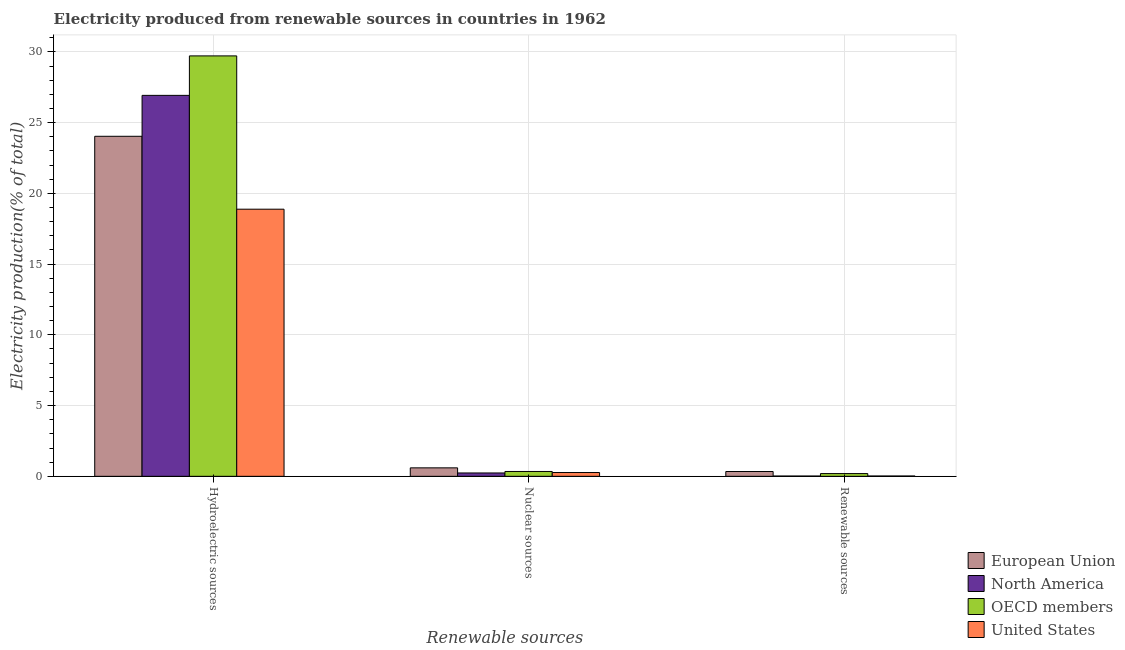How many different coloured bars are there?
Provide a succinct answer. 4. Are the number of bars per tick equal to the number of legend labels?
Ensure brevity in your answer.  Yes. Are the number of bars on each tick of the X-axis equal?
Your response must be concise. Yes. How many bars are there on the 3rd tick from the left?
Make the answer very short. 4. How many bars are there on the 3rd tick from the right?
Ensure brevity in your answer.  4. What is the label of the 2nd group of bars from the left?
Provide a succinct answer. Nuclear sources. What is the percentage of electricity produced by nuclear sources in OECD members?
Ensure brevity in your answer.  0.34. Across all countries, what is the maximum percentage of electricity produced by renewable sources?
Provide a short and direct response. 0.34. Across all countries, what is the minimum percentage of electricity produced by hydroelectric sources?
Make the answer very short. 18.88. What is the total percentage of electricity produced by hydroelectric sources in the graph?
Offer a terse response. 99.56. What is the difference between the percentage of electricity produced by hydroelectric sources in European Union and that in OECD members?
Your answer should be very brief. -5.68. What is the difference between the percentage of electricity produced by renewable sources in European Union and the percentage of electricity produced by hydroelectric sources in North America?
Offer a terse response. -26.59. What is the average percentage of electricity produced by nuclear sources per country?
Your answer should be very brief. 0.36. What is the difference between the percentage of electricity produced by renewable sources and percentage of electricity produced by hydroelectric sources in United States?
Provide a succinct answer. -18.86. In how many countries, is the percentage of electricity produced by hydroelectric sources greater than 10 %?
Give a very brief answer. 4. What is the ratio of the percentage of electricity produced by nuclear sources in North America to that in OECD members?
Your response must be concise. 0.69. Is the percentage of electricity produced by hydroelectric sources in North America less than that in United States?
Keep it short and to the point. No. What is the difference between the highest and the second highest percentage of electricity produced by hydroelectric sources?
Make the answer very short. 2.79. What is the difference between the highest and the lowest percentage of electricity produced by renewable sources?
Offer a very short reply. 0.32. In how many countries, is the percentage of electricity produced by renewable sources greater than the average percentage of electricity produced by renewable sources taken over all countries?
Keep it short and to the point. 2. What does the 3rd bar from the left in Renewable sources represents?
Offer a very short reply. OECD members. How many bars are there?
Provide a succinct answer. 12. Are all the bars in the graph horizontal?
Provide a succinct answer. No. What is the difference between two consecutive major ticks on the Y-axis?
Your answer should be compact. 5. Does the graph contain grids?
Ensure brevity in your answer.  Yes. How many legend labels are there?
Keep it short and to the point. 4. How are the legend labels stacked?
Provide a short and direct response. Vertical. What is the title of the graph?
Keep it short and to the point. Electricity produced from renewable sources in countries in 1962. What is the label or title of the X-axis?
Give a very brief answer. Renewable sources. What is the label or title of the Y-axis?
Your response must be concise. Electricity production(% of total). What is the Electricity production(% of total) of European Union in Hydroelectric sources?
Keep it short and to the point. 24.03. What is the Electricity production(% of total) of North America in Hydroelectric sources?
Your answer should be very brief. 26.93. What is the Electricity production(% of total) of OECD members in Hydroelectric sources?
Provide a succinct answer. 29.72. What is the Electricity production(% of total) in United States in Hydroelectric sources?
Keep it short and to the point. 18.88. What is the Electricity production(% of total) of European Union in Nuclear sources?
Your answer should be compact. 0.6. What is the Electricity production(% of total) of North America in Nuclear sources?
Offer a very short reply. 0.24. What is the Electricity production(% of total) in OECD members in Nuclear sources?
Offer a terse response. 0.34. What is the Electricity production(% of total) in United States in Nuclear sources?
Provide a succinct answer. 0.27. What is the Electricity production(% of total) of European Union in Renewable sources?
Make the answer very short. 0.34. What is the Electricity production(% of total) in North America in Renewable sources?
Offer a very short reply. 0.02. What is the Electricity production(% of total) of OECD members in Renewable sources?
Ensure brevity in your answer.  0.19. What is the Electricity production(% of total) in United States in Renewable sources?
Offer a very short reply. 0.02. Across all Renewable sources, what is the maximum Electricity production(% of total) in European Union?
Offer a terse response. 24.03. Across all Renewable sources, what is the maximum Electricity production(% of total) in North America?
Provide a succinct answer. 26.93. Across all Renewable sources, what is the maximum Electricity production(% of total) of OECD members?
Ensure brevity in your answer.  29.72. Across all Renewable sources, what is the maximum Electricity production(% of total) in United States?
Provide a short and direct response. 18.88. Across all Renewable sources, what is the minimum Electricity production(% of total) in European Union?
Give a very brief answer. 0.34. Across all Renewable sources, what is the minimum Electricity production(% of total) of North America?
Give a very brief answer. 0.02. Across all Renewable sources, what is the minimum Electricity production(% of total) of OECD members?
Keep it short and to the point. 0.19. Across all Renewable sources, what is the minimum Electricity production(% of total) in United States?
Your response must be concise. 0.02. What is the total Electricity production(% of total) of European Union in the graph?
Offer a very short reply. 24.97. What is the total Electricity production(% of total) in North America in the graph?
Your response must be concise. 27.18. What is the total Electricity production(% of total) of OECD members in the graph?
Your response must be concise. 30.25. What is the total Electricity production(% of total) of United States in the graph?
Make the answer very short. 19.17. What is the difference between the Electricity production(% of total) in European Union in Hydroelectric sources and that in Nuclear sources?
Give a very brief answer. 23.43. What is the difference between the Electricity production(% of total) of North America in Hydroelectric sources and that in Nuclear sources?
Ensure brevity in your answer.  26.69. What is the difference between the Electricity production(% of total) of OECD members in Hydroelectric sources and that in Nuclear sources?
Offer a terse response. 29.37. What is the difference between the Electricity production(% of total) in United States in Hydroelectric sources and that in Nuclear sources?
Your response must be concise. 18.61. What is the difference between the Electricity production(% of total) in European Union in Hydroelectric sources and that in Renewable sources?
Your response must be concise. 23.69. What is the difference between the Electricity production(% of total) in North America in Hydroelectric sources and that in Renewable sources?
Make the answer very short. 26.91. What is the difference between the Electricity production(% of total) of OECD members in Hydroelectric sources and that in Renewable sources?
Provide a succinct answer. 29.52. What is the difference between the Electricity production(% of total) of United States in Hydroelectric sources and that in Renewable sources?
Make the answer very short. 18.86. What is the difference between the Electricity production(% of total) in European Union in Nuclear sources and that in Renewable sources?
Your answer should be compact. 0.26. What is the difference between the Electricity production(% of total) in North America in Nuclear sources and that in Renewable sources?
Keep it short and to the point. 0.22. What is the difference between the Electricity production(% of total) of OECD members in Nuclear sources and that in Renewable sources?
Offer a very short reply. 0.15. What is the difference between the Electricity production(% of total) in United States in Nuclear sources and that in Renewable sources?
Your answer should be very brief. 0.25. What is the difference between the Electricity production(% of total) of European Union in Hydroelectric sources and the Electricity production(% of total) of North America in Nuclear sources?
Ensure brevity in your answer.  23.8. What is the difference between the Electricity production(% of total) in European Union in Hydroelectric sources and the Electricity production(% of total) in OECD members in Nuclear sources?
Keep it short and to the point. 23.69. What is the difference between the Electricity production(% of total) of European Union in Hydroelectric sources and the Electricity production(% of total) of United States in Nuclear sources?
Offer a terse response. 23.77. What is the difference between the Electricity production(% of total) in North America in Hydroelectric sources and the Electricity production(% of total) in OECD members in Nuclear sources?
Provide a short and direct response. 26.58. What is the difference between the Electricity production(% of total) of North America in Hydroelectric sources and the Electricity production(% of total) of United States in Nuclear sources?
Keep it short and to the point. 26.66. What is the difference between the Electricity production(% of total) of OECD members in Hydroelectric sources and the Electricity production(% of total) of United States in Nuclear sources?
Offer a very short reply. 29.45. What is the difference between the Electricity production(% of total) in European Union in Hydroelectric sources and the Electricity production(% of total) in North America in Renewable sources?
Your answer should be very brief. 24.01. What is the difference between the Electricity production(% of total) in European Union in Hydroelectric sources and the Electricity production(% of total) in OECD members in Renewable sources?
Offer a terse response. 23.84. What is the difference between the Electricity production(% of total) of European Union in Hydroelectric sources and the Electricity production(% of total) of United States in Renewable sources?
Provide a succinct answer. 24.01. What is the difference between the Electricity production(% of total) of North America in Hydroelectric sources and the Electricity production(% of total) of OECD members in Renewable sources?
Give a very brief answer. 26.73. What is the difference between the Electricity production(% of total) of North America in Hydroelectric sources and the Electricity production(% of total) of United States in Renewable sources?
Keep it short and to the point. 26.9. What is the difference between the Electricity production(% of total) in OECD members in Hydroelectric sources and the Electricity production(% of total) in United States in Renewable sources?
Offer a terse response. 29.69. What is the difference between the Electricity production(% of total) of European Union in Nuclear sources and the Electricity production(% of total) of North America in Renewable sources?
Your answer should be compact. 0.58. What is the difference between the Electricity production(% of total) in European Union in Nuclear sources and the Electricity production(% of total) in OECD members in Renewable sources?
Your answer should be very brief. 0.41. What is the difference between the Electricity production(% of total) of European Union in Nuclear sources and the Electricity production(% of total) of United States in Renewable sources?
Keep it short and to the point. 0.58. What is the difference between the Electricity production(% of total) of North America in Nuclear sources and the Electricity production(% of total) of OECD members in Renewable sources?
Your answer should be very brief. 0.04. What is the difference between the Electricity production(% of total) of North America in Nuclear sources and the Electricity production(% of total) of United States in Renewable sources?
Give a very brief answer. 0.21. What is the difference between the Electricity production(% of total) in OECD members in Nuclear sources and the Electricity production(% of total) in United States in Renewable sources?
Offer a terse response. 0.32. What is the average Electricity production(% of total) in European Union per Renewable sources?
Make the answer very short. 8.32. What is the average Electricity production(% of total) in North America per Renewable sources?
Offer a very short reply. 9.06. What is the average Electricity production(% of total) of OECD members per Renewable sources?
Provide a succinct answer. 10.08. What is the average Electricity production(% of total) in United States per Renewable sources?
Make the answer very short. 6.39. What is the difference between the Electricity production(% of total) in European Union and Electricity production(% of total) in North America in Hydroelectric sources?
Your response must be concise. -2.89. What is the difference between the Electricity production(% of total) in European Union and Electricity production(% of total) in OECD members in Hydroelectric sources?
Your answer should be very brief. -5.68. What is the difference between the Electricity production(% of total) of European Union and Electricity production(% of total) of United States in Hydroelectric sources?
Ensure brevity in your answer.  5.15. What is the difference between the Electricity production(% of total) in North America and Electricity production(% of total) in OECD members in Hydroelectric sources?
Provide a short and direct response. -2.79. What is the difference between the Electricity production(% of total) in North America and Electricity production(% of total) in United States in Hydroelectric sources?
Keep it short and to the point. 8.04. What is the difference between the Electricity production(% of total) of OECD members and Electricity production(% of total) of United States in Hydroelectric sources?
Provide a succinct answer. 10.83. What is the difference between the Electricity production(% of total) of European Union and Electricity production(% of total) of North America in Nuclear sources?
Offer a terse response. 0.36. What is the difference between the Electricity production(% of total) of European Union and Electricity production(% of total) of OECD members in Nuclear sources?
Offer a terse response. 0.26. What is the difference between the Electricity production(% of total) in European Union and Electricity production(% of total) in United States in Nuclear sources?
Provide a succinct answer. 0.33. What is the difference between the Electricity production(% of total) in North America and Electricity production(% of total) in OECD members in Nuclear sources?
Make the answer very short. -0.11. What is the difference between the Electricity production(% of total) of North America and Electricity production(% of total) of United States in Nuclear sources?
Give a very brief answer. -0.03. What is the difference between the Electricity production(% of total) of OECD members and Electricity production(% of total) of United States in Nuclear sources?
Make the answer very short. 0.07. What is the difference between the Electricity production(% of total) of European Union and Electricity production(% of total) of North America in Renewable sources?
Keep it short and to the point. 0.32. What is the difference between the Electricity production(% of total) of European Union and Electricity production(% of total) of OECD members in Renewable sources?
Keep it short and to the point. 0.15. What is the difference between the Electricity production(% of total) in European Union and Electricity production(% of total) in United States in Renewable sources?
Offer a very short reply. 0.32. What is the difference between the Electricity production(% of total) of North America and Electricity production(% of total) of OECD members in Renewable sources?
Your answer should be compact. -0.17. What is the difference between the Electricity production(% of total) of North America and Electricity production(% of total) of United States in Renewable sources?
Provide a short and direct response. -0. What is the difference between the Electricity production(% of total) in OECD members and Electricity production(% of total) in United States in Renewable sources?
Your answer should be very brief. 0.17. What is the ratio of the Electricity production(% of total) in European Union in Hydroelectric sources to that in Nuclear sources?
Offer a terse response. 40.13. What is the ratio of the Electricity production(% of total) in North America in Hydroelectric sources to that in Nuclear sources?
Provide a succinct answer. 113.49. What is the ratio of the Electricity production(% of total) of OECD members in Hydroelectric sources to that in Nuclear sources?
Your answer should be compact. 86.7. What is the ratio of the Electricity production(% of total) in United States in Hydroelectric sources to that in Nuclear sources?
Make the answer very short. 70.27. What is the ratio of the Electricity production(% of total) of European Union in Hydroelectric sources to that in Renewable sources?
Offer a terse response. 70.73. What is the ratio of the Electricity production(% of total) of North America in Hydroelectric sources to that in Renewable sources?
Your answer should be very brief. 1338.16. What is the ratio of the Electricity production(% of total) of OECD members in Hydroelectric sources to that in Renewable sources?
Your answer should be very brief. 153.58. What is the ratio of the Electricity production(% of total) of United States in Hydroelectric sources to that in Renewable sources?
Keep it short and to the point. 828.59. What is the ratio of the Electricity production(% of total) in European Union in Nuclear sources to that in Renewable sources?
Your answer should be very brief. 1.76. What is the ratio of the Electricity production(% of total) of North America in Nuclear sources to that in Renewable sources?
Provide a succinct answer. 11.79. What is the ratio of the Electricity production(% of total) of OECD members in Nuclear sources to that in Renewable sources?
Give a very brief answer. 1.77. What is the ratio of the Electricity production(% of total) of United States in Nuclear sources to that in Renewable sources?
Provide a succinct answer. 11.79. What is the difference between the highest and the second highest Electricity production(% of total) of European Union?
Provide a short and direct response. 23.43. What is the difference between the highest and the second highest Electricity production(% of total) in North America?
Offer a terse response. 26.69. What is the difference between the highest and the second highest Electricity production(% of total) of OECD members?
Provide a short and direct response. 29.37. What is the difference between the highest and the second highest Electricity production(% of total) of United States?
Make the answer very short. 18.61. What is the difference between the highest and the lowest Electricity production(% of total) in European Union?
Offer a terse response. 23.69. What is the difference between the highest and the lowest Electricity production(% of total) of North America?
Your answer should be very brief. 26.91. What is the difference between the highest and the lowest Electricity production(% of total) of OECD members?
Keep it short and to the point. 29.52. What is the difference between the highest and the lowest Electricity production(% of total) in United States?
Offer a very short reply. 18.86. 